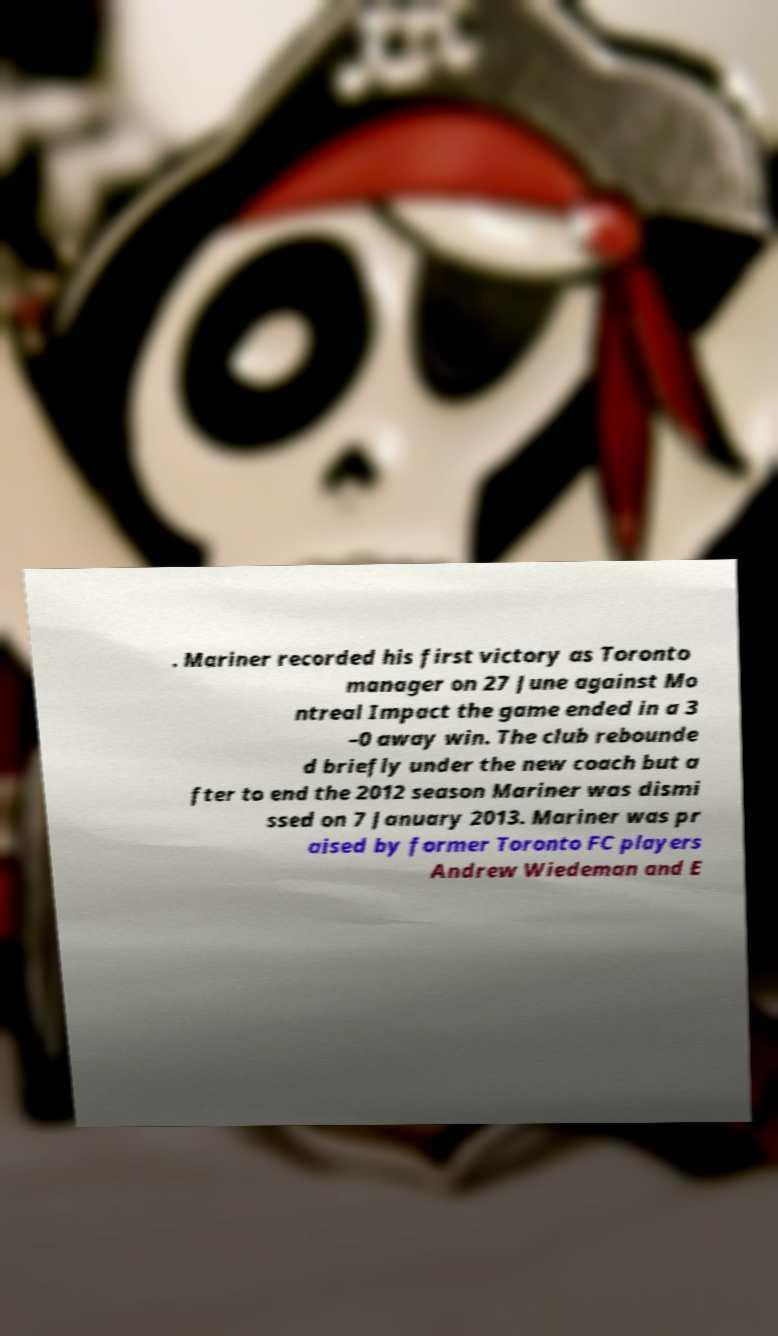What messages or text are displayed in this image? I need them in a readable, typed format. . Mariner recorded his first victory as Toronto manager on 27 June against Mo ntreal Impact the game ended in a 3 –0 away win. The club rebounde d briefly under the new coach but a fter to end the 2012 season Mariner was dismi ssed on 7 January 2013. Mariner was pr aised by former Toronto FC players Andrew Wiedeman and E 